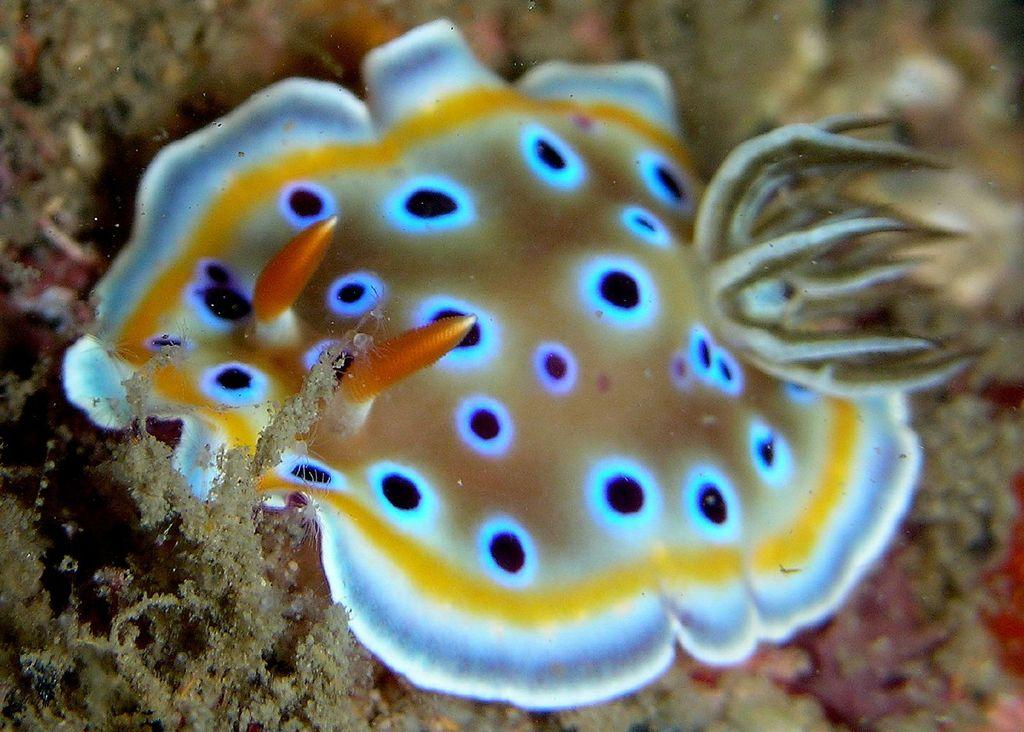What type of animals can be seen in the image? There are water species in the image. Where are the water species located? The water species are on the sand and inside the water. What advice can be given to the water species in the image? There is no need to give advice to the water species in the image, as they are not capable of understanding or following human advice. 